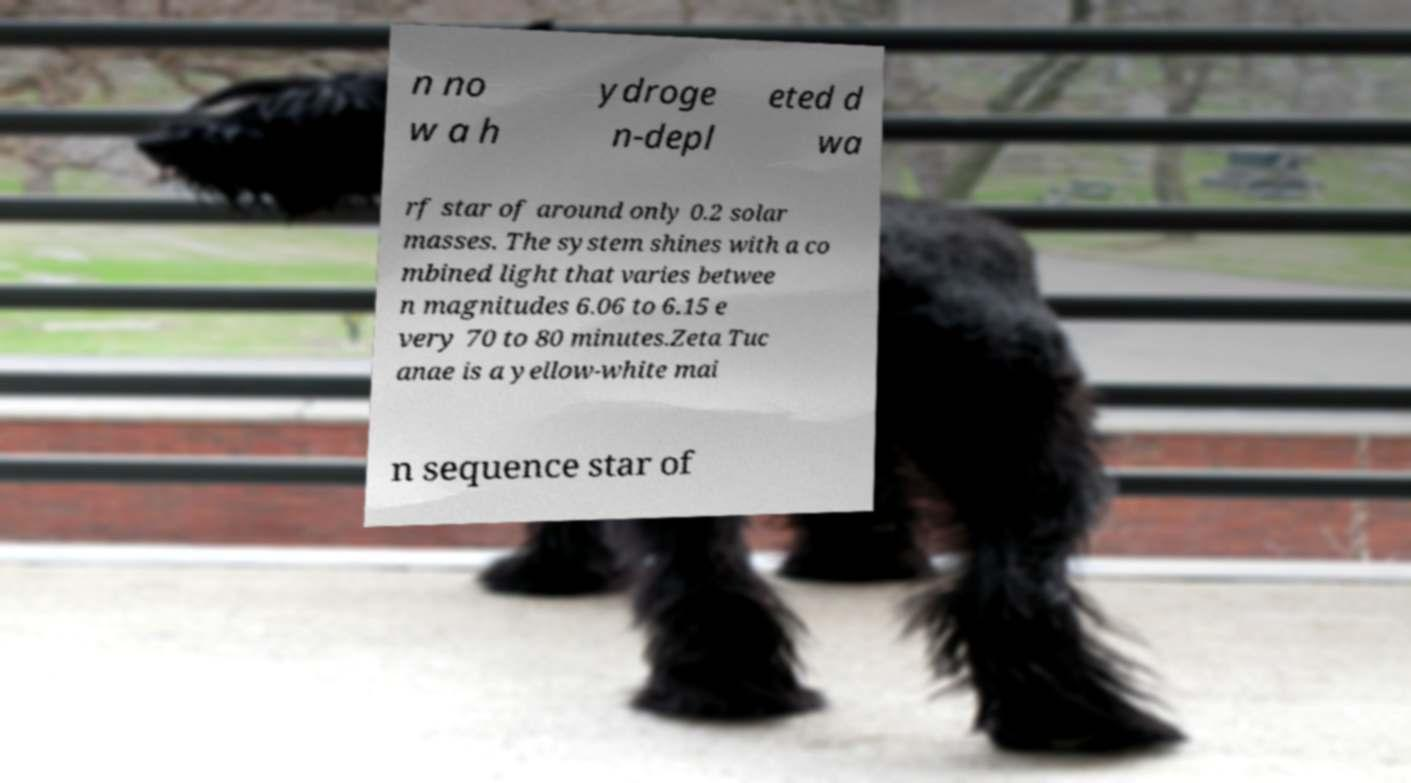Can you read and provide the text displayed in the image?This photo seems to have some interesting text. Can you extract and type it out for me? n no w a h ydroge n-depl eted d wa rf star of around only 0.2 solar masses. The system shines with a co mbined light that varies betwee n magnitudes 6.06 to 6.15 e very 70 to 80 minutes.Zeta Tuc anae is a yellow-white mai n sequence star of 